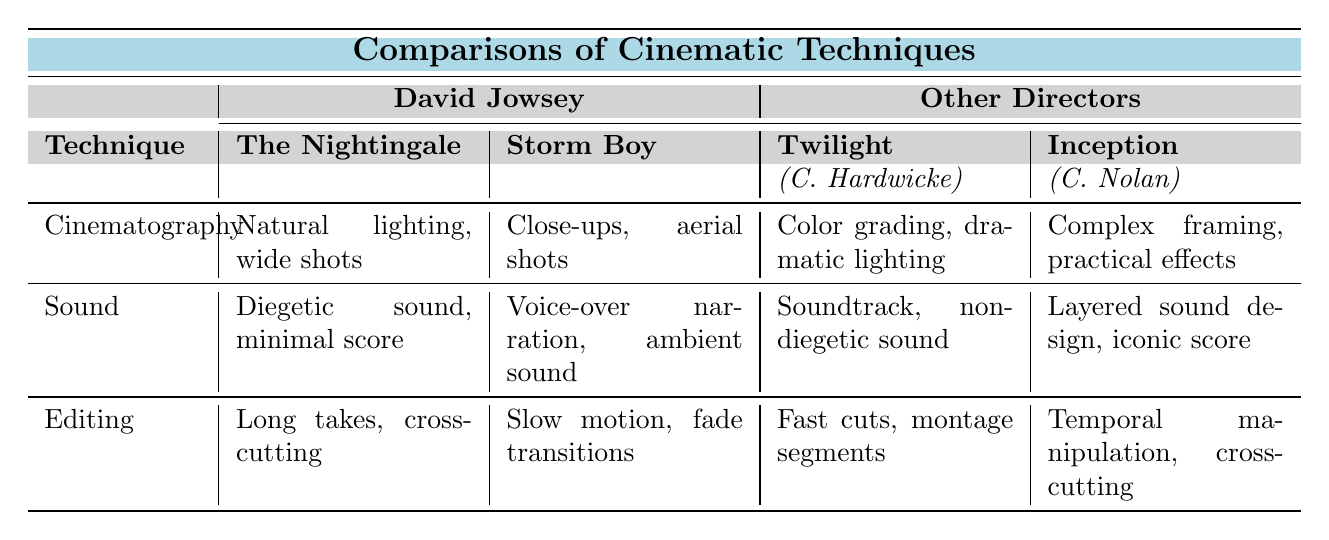What cinematic technique is used in "The Nightingale"? In the table, under the "The Nightingale" row, the cinematic techniques listed are "Natural lighting, wide shots" under the Cinematography category.
Answer: Natural lighting, wide shots Which director's films use soundtracks? In the provided table, Catherine Hardwicke's film "Twilight" has "Soundtrack, non-diegetic sound" listed under the Sound category.
Answer: Catherine Hardwicke What is the primary editing technique used in "Storm Boy"? "Storm Boy" shows "Slow motion, fade transitions" as its editing technique in the corresponding row.
Answer: Slow motion, fade transitions Which director has a film noted for its use of non-linear narrative editing? Christopher Nolan's film "Dunkirk" is noted for its "Non-linear narrative" editing technique as mentioned in its row.
Answer: Christopher Nolan Is the sound technique used in "The Nightingale" diegetic? The table indicates that "The Nightingale" employs "Diegetic sound, minimal score" under the Sound category, confirming it is indeed diegetic.
Answer: Yes Compare the cinematography techniques of "Twilight" and "Inception". "Twilight" employs "Color grading, dramatic lighting" while "Inception" uses "Complex framing, practical effects"; thus, their techniques differ in style and method.
Answer: They differ How many films by other directors are mentioned in the table? The table includes two other directors, each with two films, resulting in a total of four films.
Answer: Four films Which film by David Jowsey features cross-cutting in its editing? In the table, "The Nightingale" is identified as having "Long takes, cross-cutting" as its editing technique.
Answer: The Nightingale What difference exists in the sound techniques between David Jowsey's films and those of Catherine Hardwicke? Jowsey's films include diegetic sounds and minimal scores, whereas Hardwicke's films utilize soundtracks and non-diegetic sounds, highlighting contrasting approaches to sound design.
Answer: Contrasting approaches Analyze the editing techniques listed for both David Jowsey's films. For "The Nightingale," the editing technique is "Long takes, cross-cutting," while "Storm Boy" features "Slow motion, fade transitions," indicating different strategies that both films employ for pacing and narrative flow.
Answer: Different strategies 